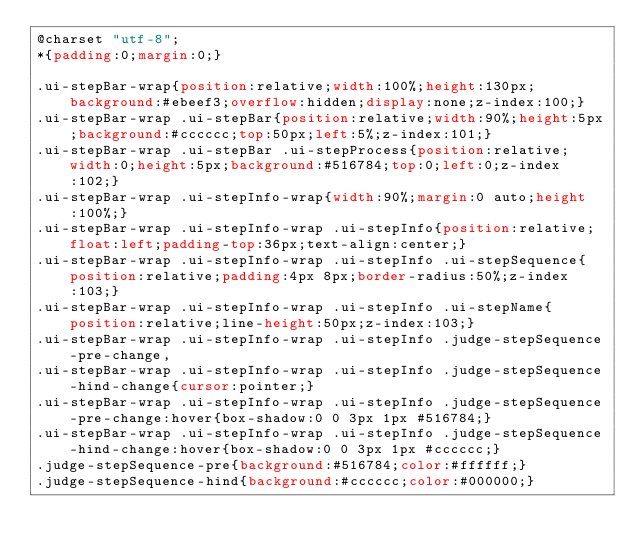Convert code to text. <code><loc_0><loc_0><loc_500><loc_500><_CSS_>@charset "utf-8";
*{padding:0;margin:0;}

.ui-stepBar-wrap{position:relative;width:100%;height:130px;background:#ebeef3;overflow:hidden;display:none;z-index:100;}
.ui-stepBar-wrap .ui-stepBar{position:relative;width:90%;height:5px;background:#cccccc;top:50px;left:5%;z-index:101;}
.ui-stepBar-wrap .ui-stepBar .ui-stepProcess{position:relative;width:0;height:5px;background:#516784;top:0;left:0;z-index:102;}
.ui-stepBar-wrap .ui-stepInfo-wrap{width:90%;margin:0 auto;height:100%;}
.ui-stepBar-wrap .ui-stepInfo-wrap .ui-stepInfo{position:relative;float:left;padding-top:36px;text-align:center;}
.ui-stepBar-wrap .ui-stepInfo-wrap .ui-stepInfo .ui-stepSequence{position:relative;padding:4px 8px;border-radius:50%;z-index:103;}
.ui-stepBar-wrap .ui-stepInfo-wrap .ui-stepInfo .ui-stepName{position:relative;line-height:50px;z-index:103;}
.ui-stepBar-wrap .ui-stepInfo-wrap .ui-stepInfo .judge-stepSequence-pre-change,
.ui-stepBar-wrap .ui-stepInfo-wrap .ui-stepInfo .judge-stepSequence-hind-change{cursor:pointer;}
.ui-stepBar-wrap .ui-stepInfo-wrap .ui-stepInfo .judge-stepSequence-pre-change:hover{box-shadow:0 0 3px 1px #516784;}
.ui-stepBar-wrap .ui-stepInfo-wrap .ui-stepInfo .judge-stepSequence-hind-change:hover{box-shadow:0 0 3px 1px #cccccc;}
.judge-stepSequence-pre{background:#516784;color:#ffffff;}
.judge-stepSequence-hind{background:#cccccc;color:#000000;}
</code> 